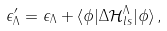<formula> <loc_0><loc_0><loc_500><loc_500>\epsilon _ { \Lambda } ^ { \prime } = \epsilon _ { \Lambda } + \langle \phi | \Delta \mathcal { H } _ { l s } ^ { \Lambda } | \phi \rangle \, ,</formula> 